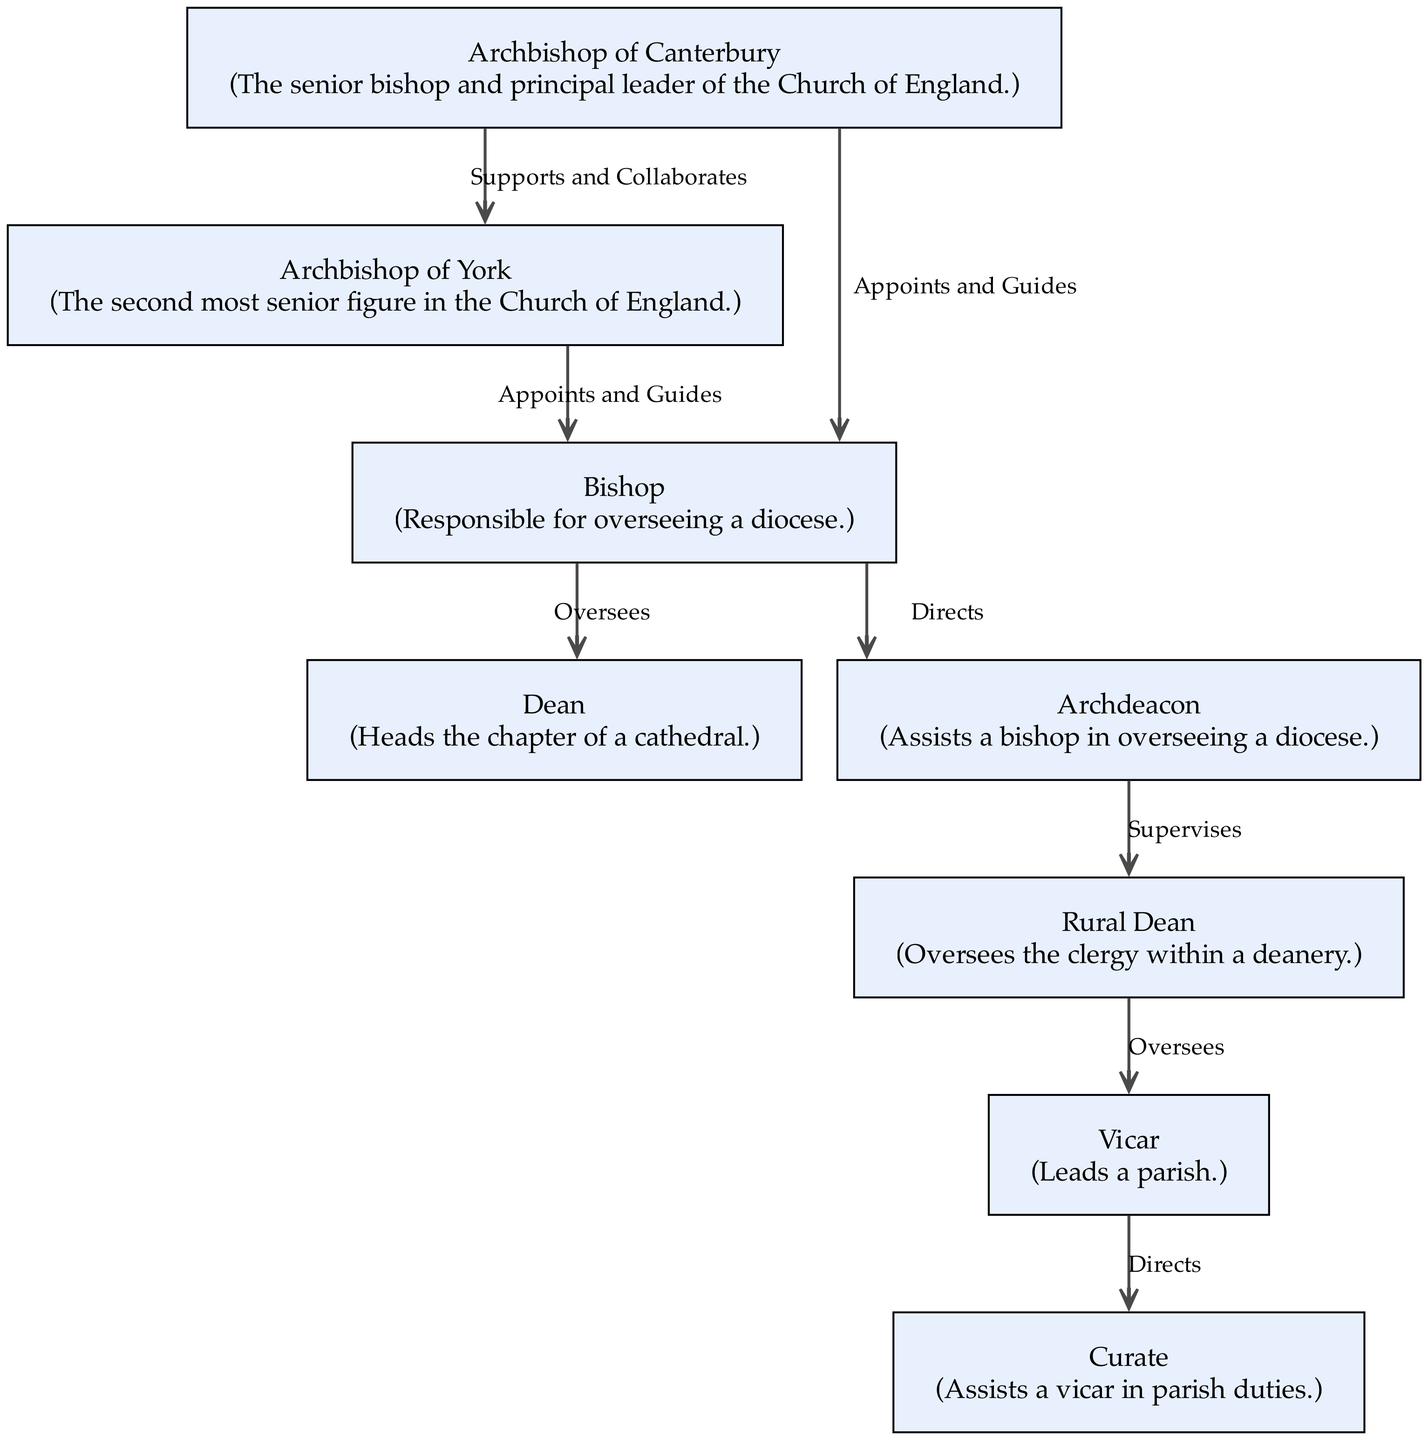What is the highest position in the Anglican Church hierarchy? The diagram shows the "Archbishop of Canterbury" at the top, indicating it is the highest position in the Church of England hierarchy.
Answer: Archbishop of Canterbury How many nodes are there in the diagram? By counting each unique role presented as nodes in the diagram, we find there are eight distinct roles listed.
Answer: 8 What role does the Bishop oversee? The diagram indicates that the "Bishop" oversees the "Dean" and the "Archdeacon," thus taking on a supervisory role over these two.
Answer: Dean, Archdeacon Who collaborates with the Archbishop of Canterbury? The diagram illustrates the connection labeled "Supports and Collaborates" between the "Archbishop of Canterbury" and the "Archbishop of York," showing their collaborative relationship.
Answer: Archbishop of York What role is directly supervised by the Archdeacon? The diagram shows an edge labeled "Supervises" from "Archdeacon" to "Rural Dean," indicating that the Rural Dean is under supervision from the Archdeacon.
Answer: Rural Dean How many edges connect the Bishop to other roles? Counting the outgoing edges from the "Bishop," we see there are three connections: one to the Dean, one to the Archdeacon, and one to the two Archbishops, totaling three.
Answer: 3 Which role assists a Vicar? The diagram shows an edge labeled "Directs" from "Vicar" to "Curate," indicating that the Curate assists the Vicar with parish duties.
Answer: Curate What label indicates the relationship between the Archbishop of York and the Bishop? The diagram states the relationship is defined by the label "Appoints and Guides," which shows how the Archbishop of York interacts with the Bishop.
Answer: Appoints and Guides 